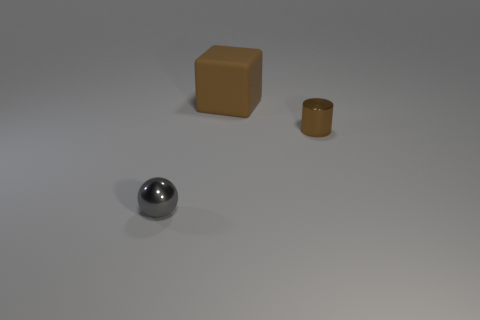Add 2 gray metallic things. How many objects exist? 5 Subtract all cylinders. How many objects are left? 2 Add 2 gray metal things. How many gray metal things are left? 3 Add 2 big purple balls. How many big purple balls exist? 2 Subtract 0 blue blocks. How many objects are left? 3 Subtract all purple matte balls. Subtract all small gray objects. How many objects are left? 2 